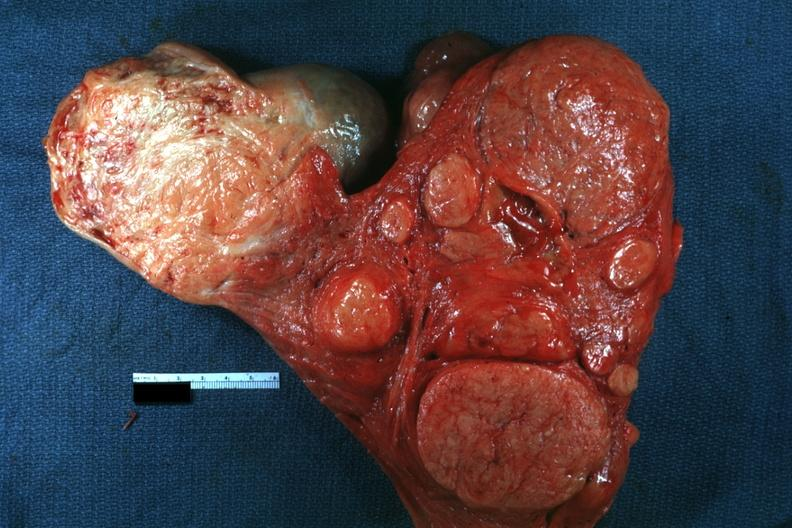what is present?
Answer the question using a single word or phrase. Leiomyomas 